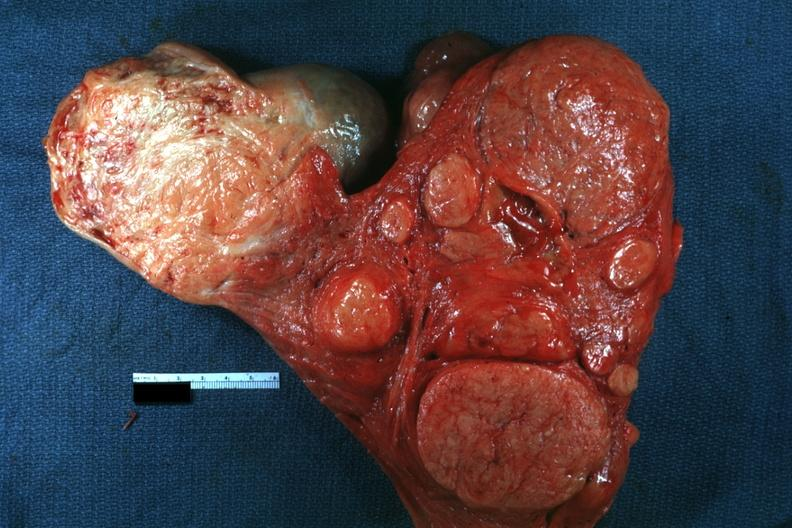what is present?
Answer the question using a single word or phrase. Leiomyomas 